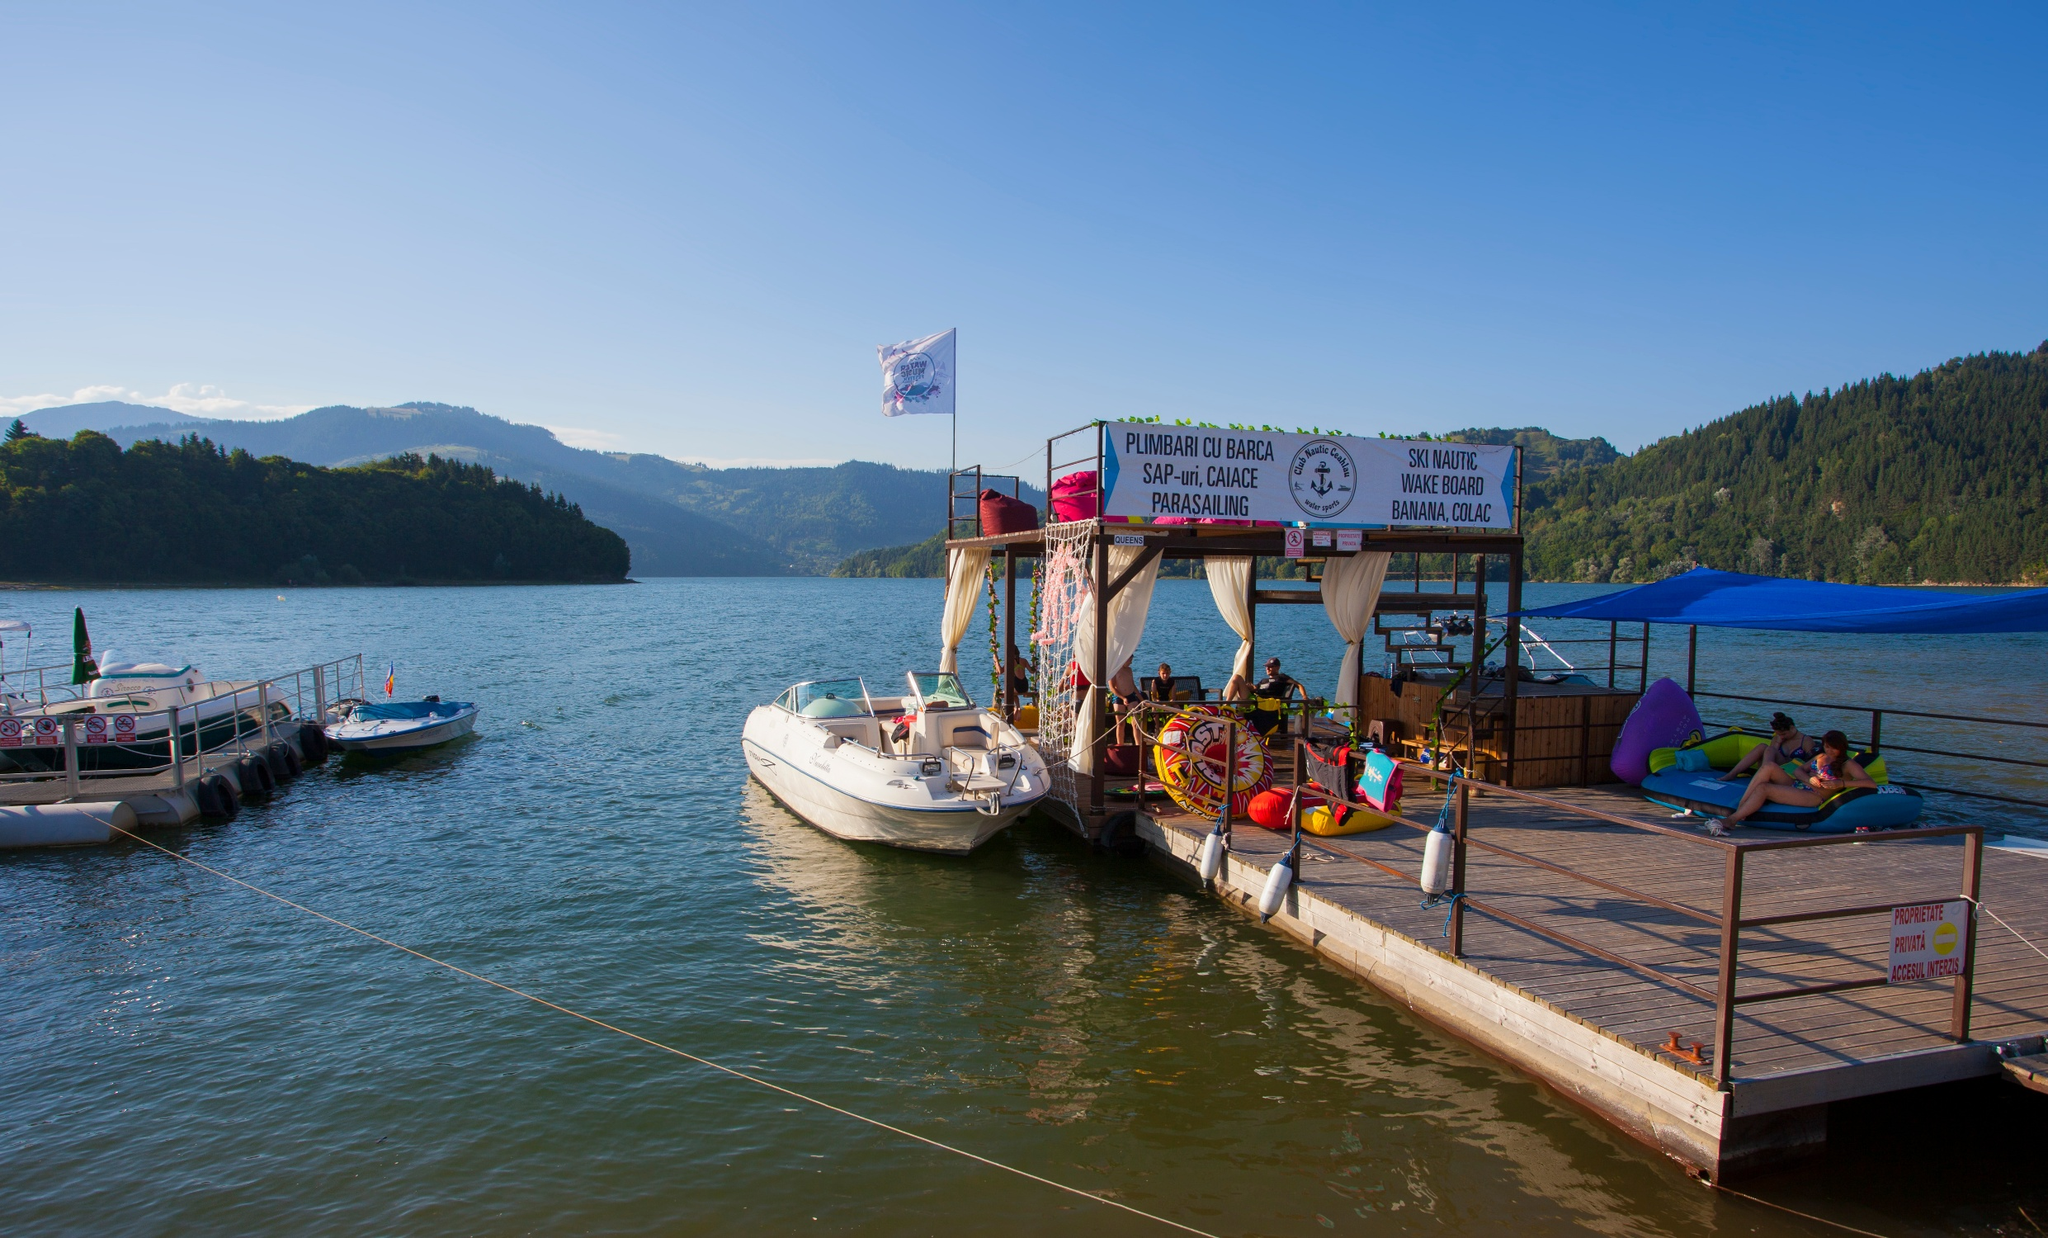What do you see happening in this image? The image showcases a vibrant and bustling recreational spot by the lake. A pontoon hosts water activity options such as boat rides, water skiing, wakeboarding, and parasailing, as advertised by the signage. The atmosphere is leisurely, with people lounging on colorful floats. The surrounding landscape features rolling hills in the distance, framing the lake beautifully. The sky is clear and blue, offering a perfect day for lakeside activities. The scene is captured from the perspective of a visitor looking out towards the water, perhaps contemplating which activity to indulge in. 